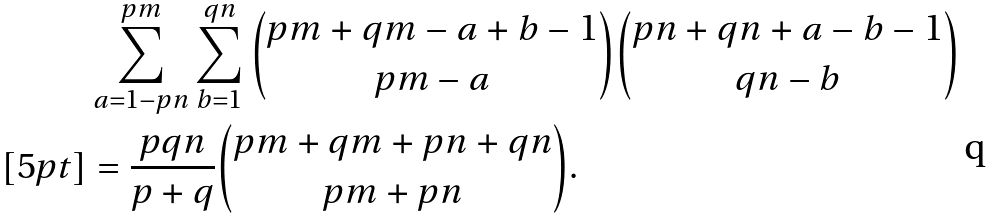Convert formula to latex. <formula><loc_0><loc_0><loc_500><loc_500>& \sum _ { a = 1 - p n } ^ { p m } \sum _ { b = 1 } ^ { q n } { p m + q m - a + b - 1 \choose p m - a } { p n + q n + a - b - 1 \choose q n - b } \\ [ 5 p t ] & = \frac { p q n } { p + q } { p m + q m + p n + q n \choose p m + p n } .</formula> 